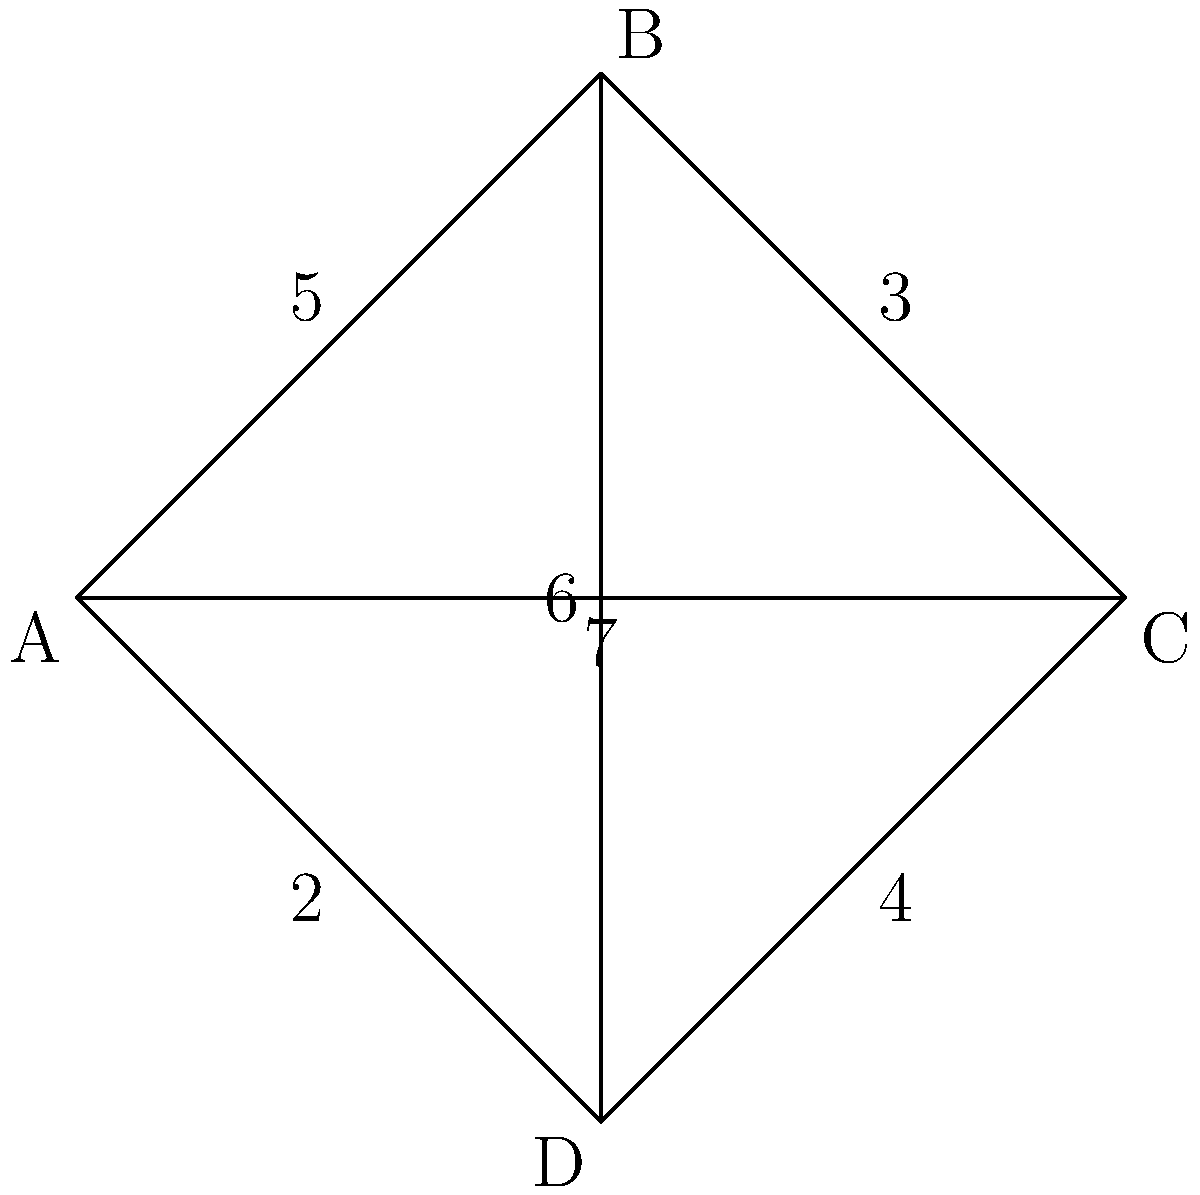In the network diagram above, each edge represents a signal path with its associated latency (in milliseconds). What is the minimum total latency required to transmit a signal from node A to node C while passing through either node B or node D? To solve this problem, we need to consider two possible paths from A to C:

1. Path through B: A → B → C
2. Path through D: A → D → C

Let's calculate the latency for each path:

1. Path through B:
   A → B latency: 5 ms
   B → C latency: 3 ms
   Total latency = 5 + 3 = 8 ms

2. Path through D:
   A → D latency: 2 ms
   D → C latency: 4 ms
   Total latency = 2 + 4 = 6 ms

The minimum total latency is the smaller of these two values: min(8, 6) = 6 ms.

Note that we don't consider the direct path A → C (with latency 7 ms) because the question specifically asks for a path through either B or D.
Answer: 6 ms 